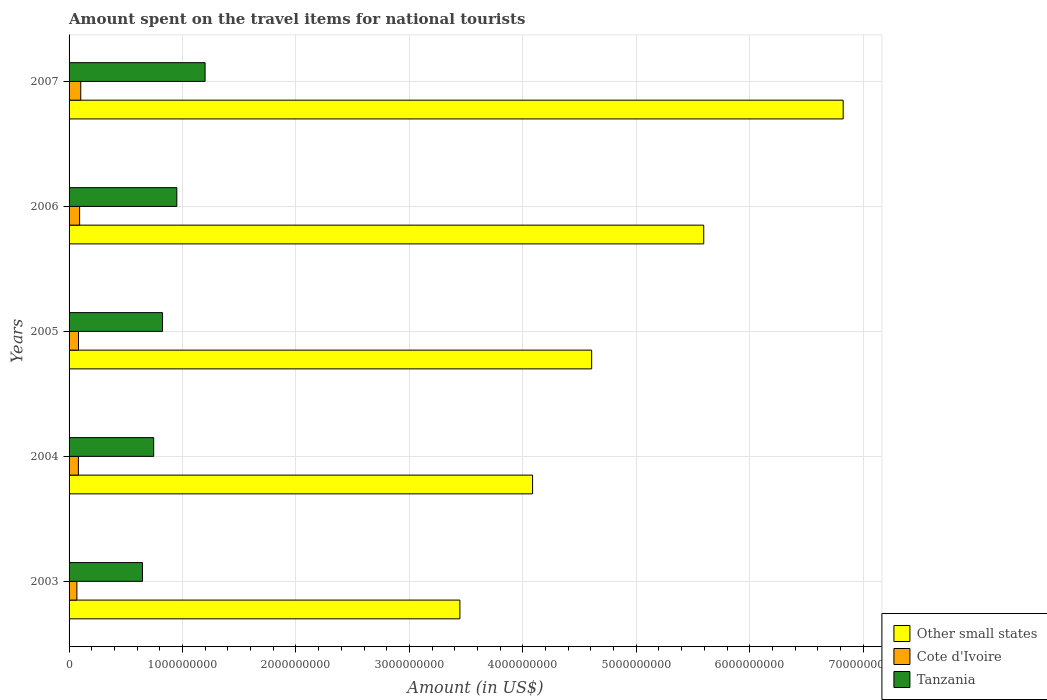How many different coloured bars are there?
Provide a short and direct response. 3. How many groups of bars are there?
Your answer should be very brief. 5. How many bars are there on the 3rd tick from the top?
Your answer should be compact. 3. How many bars are there on the 2nd tick from the bottom?
Make the answer very short. 3. What is the label of the 4th group of bars from the top?
Give a very brief answer. 2004. What is the amount spent on the travel items for national tourists in Other small states in 2005?
Provide a succinct answer. 4.61e+09. Across all years, what is the maximum amount spent on the travel items for national tourists in Other small states?
Your answer should be very brief. 6.82e+09. Across all years, what is the minimum amount spent on the travel items for national tourists in Other small states?
Ensure brevity in your answer.  3.45e+09. In which year was the amount spent on the travel items for national tourists in Tanzania maximum?
Ensure brevity in your answer.  2007. What is the total amount spent on the travel items for national tourists in Other small states in the graph?
Provide a succinct answer. 2.46e+1. What is the difference between the amount spent on the travel items for national tourists in Cote d'Ivoire in 2003 and that in 2007?
Your answer should be very brief. -3.40e+07. What is the difference between the amount spent on the travel items for national tourists in Cote d'Ivoire in 2007 and the amount spent on the travel items for national tourists in Tanzania in 2003?
Your answer should be compact. -5.44e+08. What is the average amount spent on the travel items for national tourists in Other small states per year?
Offer a very short reply. 4.91e+09. In the year 2004, what is the difference between the amount spent on the travel items for national tourists in Other small states and amount spent on the travel items for national tourists in Tanzania?
Offer a terse response. 3.34e+09. In how many years, is the amount spent on the travel items for national tourists in Cote d'Ivoire greater than 4200000000 US$?
Keep it short and to the point. 0. What is the ratio of the amount spent on the travel items for national tourists in Tanzania in 2006 to that in 2007?
Your answer should be very brief. 0.79. Is the difference between the amount spent on the travel items for national tourists in Other small states in 2003 and 2005 greater than the difference between the amount spent on the travel items for national tourists in Tanzania in 2003 and 2005?
Provide a short and direct response. No. What is the difference between the highest and the second highest amount spent on the travel items for national tourists in Other small states?
Your answer should be very brief. 1.23e+09. What is the difference between the highest and the lowest amount spent on the travel items for national tourists in Other small states?
Keep it short and to the point. 3.38e+09. In how many years, is the amount spent on the travel items for national tourists in Other small states greater than the average amount spent on the travel items for national tourists in Other small states taken over all years?
Your answer should be compact. 2. Is the sum of the amount spent on the travel items for national tourists in Tanzania in 2004 and 2006 greater than the maximum amount spent on the travel items for national tourists in Other small states across all years?
Your answer should be very brief. No. What does the 1st bar from the top in 2004 represents?
Make the answer very short. Tanzania. What does the 1st bar from the bottom in 2003 represents?
Make the answer very short. Other small states. How many bars are there?
Your answer should be very brief. 15. How many years are there in the graph?
Your answer should be compact. 5. Are the values on the major ticks of X-axis written in scientific E-notation?
Give a very brief answer. No. Does the graph contain grids?
Keep it short and to the point. Yes. Where does the legend appear in the graph?
Offer a terse response. Bottom right. How many legend labels are there?
Offer a terse response. 3. What is the title of the graph?
Provide a short and direct response. Amount spent on the travel items for national tourists. What is the label or title of the X-axis?
Offer a very short reply. Amount (in US$). What is the label or title of the Y-axis?
Give a very brief answer. Years. What is the Amount (in US$) of Other small states in 2003?
Ensure brevity in your answer.  3.45e+09. What is the Amount (in US$) of Cote d'Ivoire in 2003?
Your answer should be very brief. 6.90e+07. What is the Amount (in US$) in Tanzania in 2003?
Ensure brevity in your answer.  6.47e+08. What is the Amount (in US$) in Other small states in 2004?
Provide a short and direct response. 4.09e+09. What is the Amount (in US$) in Cote d'Ivoire in 2004?
Your response must be concise. 8.20e+07. What is the Amount (in US$) of Tanzania in 2004?
Provide a short and direct response. 7.46e+08. What is the Amount (in US$) in Other small states in 2005?
Your response must be concise. 4.61e+09. What is the Amount (in US$) of Cote d'Ivoire in 2005?
Offer a terse response. 8.30e+07. What is the Amount (in US$) in Tanzania in 2005?
Your answer should be very brief. 8.24e+08. What is the Amount (in US$) in Other small states in 2006?
Your answer should be compact. 5.59e+09. What is the Amount (in US$) of Cote d'Ivoire in 2006?
Offer a terse response. 9.30e+07. What is the Amount (in US$) in Tanzania in 2006?
Offer a terse response. 9.50e+08. What is the Amount (in US$) in Other small states in 2007?
Make the answer very short. 6.82e+09. What is the Amount (in US$) of Cote d'Ivoire in 2007?
Make the answer very short. 1.03e+08. What is the Amount (in US$) in Tanzania in 2007?
Offer a terse response. 1.20e+09. Across all years, what is the maximum Amount (in US$) of Other small states?
Your answer should be compact. 6.82e+09. Across all years, what is the maximum Amount (in US$) in Cote d'Ivoire?
Your response must be concise. 1.03e+08. Across all years, what is the maximum Amount (in US$) in Tanzania?
Ensure brevity in your answer.  1.20e+09. Across all years, what is the minimum Amount (in US$) in Other small states?
Ensure brevity in your answer.  3.45e+09. Across all years, what is the minimum Amount (in US$) of Cote d'Ivoire?
Provide a succinct answer. 6.90e+07. Across all years, what is the minimum Amount (in US$) of Tanzania?
Provide a succinct answer. 6.47e+08. What is the total Amount (in US$) of Other small states in the graph?
Offer a very short reply. 2.46e+1. What is the total Amount (in US$) of Cote d'Ivoire in the graph?
Give a very brief answer. 4.30e+08. What is the total Amount (in US$) in Tanzania in the graph?
Make the answer very short. 4.37e+09. What is the difference between the Amount (in US$) in Other small states in 2003 and that in 2004?
Your response must be concise. -6.41e+08. What is the difference between the Amount (in US$) of Cote d'Ivoire in 2003 and that in 2004?
Ensure brevity in your answer.  -1.30e+07. What is the difference between the Amount (in US$) of Tanzania in 2003 and that in 2004?
Give a very brief answer. -9.90e+07. What is the difference between the Amount (in US$) in Other small states in 2003 and that in 2005?
Give a very brief answer. -1.16e+09. What is the difference between the Amount (in US$) in Cote d'Ivoire in 2003 and that in 2005?
Offer a very short reply. -1.40e+07. What is the difference between the Amount (in US$) in Tanzania in 2003 and that in 2005?
Provide a succinct answer. -1.77e+08. What is the difference between the Amount (in US$) of Other small states in 2003 and that in 2006?
Keep it short and to the point. -2.15e+09. What is the difference between the Amount (in US$) in Cote d'Ivoire in 2003 and that in 2006?
Ensure brevity in your answer.  -2.40e+07. What is the difference between the Amount (in US$) of Tanzania in 2003 and that in 2006?
Your response must be concise. -3.03e+08. What is the difference between the Amount (in US$) in Other small states in 2003 and that in 2007?
Your response must be concise. -3.38e+09. What is the difference between the Amount (in US$) of Cote d'Ivoire in 2003 and that in 2007?
Your answer should be compact. -3.40e+07. What is the difference between the Amount (in US$) of Tanzania in 2003 and that in 2007?
Your answer should be very brief. -5.52e+08. What is the difference between the Amount (in US$) of Other small states in 2004 and that in 2005?
Provide a short and direct response. -5.21e+08. What is the difference between the Amount (in US$) in Tanzania in 2004 and that in 2005?
Give a very brief answer. -7.80e+07. What is the difference between the Amount (in US$) in Other small states in 2004 and that in 2006?
Your answer should be very brief. -1.51e+09. What is the difference between the Amount (in US$) of Cote d'Ivoire in 2004 and that in 2006?
Keep it short and to the point. -1.10e+07. What is the difference between the Amount (in US$) of Tanzania in 2004 and that in 2006?
Offer a terse response. -2.04e+08. What is the difference between the Amount (in US$) in Other small states in 2004 and that in 2007?
Make the answer very short. -2.74e+09. What is the difference between the Amount (in US$) in Cote d'Ivoire in 2004 and that in 2007?
Give a very brief answer. -2.10e+07. What is the difference between the Amount (in US$) of Tanzania in 2004 and that in 2007?
Make the answer very short. -4.53e+08. What is the difference between the Amount (in US$) of Other small states in 2005 and that in 2006?
Make the answer very short. -9.88e+08. What is the difference between the Amount (in US$) of Cote d'Ivoire in 2005 and that in 2006?
Your response must be concise. -1.00e+07. What is the difference between the Amount (in US$) in Tanzania in 2005 and that in 2006?
Make the answer very short. -1.26e+08. What is the difference between the Amount (in US$) of Other small states in 2005 and that in 2007?
Give a very brief answer. -2.22e+09. What is the difference between the Amount (in US$) in Cote d'Ivoire in 2005 and that in 2007?
Offer a very short reply. -2.00e+07. What is the difference between the Amount (in US$) in Tanzania in 2005 and that in 2007?
Offer a terse response. -3.75e+08. What is the difference between the Amount (in US$) of Other small states in 2006 and that in 2007?
Offer a very short reply. -1.23e+09. What is the difference between the Amount (in US$) of Cote d'Ivoire in 2006 and that in 2007?
Your answer should be very brief. -1.00e+07. What is the difference between the Amount (in US$) in Tanzania in 2006 and that in 2007?
Provide a short and direct response. -2.49e+08. What is the difference between the Amount (in US$) in Other small states in 2003 and the Amount (in US$) in Cote d'Ivoire in 2004?
Your answer should be compact. 3.36e+09. What is the difference between the Amount (in US$) in Other small states in 2003 and the Amount (in US$) in Tanzania in 2004?
Keep it short and to the point. 2.70e+09. What is the difference between the Amount (in US$) of Cote d'Ivoire in 2003 and the Amount (in US$) of Tanzania in 2004?
Offer a very short reply. -6.77e+08. What is the difference between the Amount (in US$) of Other small states in 2003 and the Amount (in US$) of Cote d'Ivoire in 2005?
Provide a succinct answer. 3.36e+09. What is the difference between the Amount (in US$) of Other small states in 2003 and the Amount (in US$) of Tanzania in 2005?
Your response must be concise. 2.62e+09. What is the difference between the Amount (in US$) in Cote d'Ivoire in 2003 and the Amount (in US$) in Tanzania in 2005?
Make the answer very short. -7.55e+08. What is the difference between the Amount (in US$) in Other small states in 2003 and the Amount (in US$) in Cote d'Ivoire in 2006?
Provide a short and direct response. 3.35e+09. What is the difference between the Amount (in US$) of Other small states in 2003 and the Amount (in US$) of Tanzania in 2006?
Your answer should be very brief. 2.50e+09. What is the difference between the Amount (in US$) in Cote d'Ivoire in 2003 and the Amount (in US$) in Tanzania in 2006?
Offer a terse response. -8.81e+08. What is the difference between the Amount (in US$) of Other small states in 2003 and the Amount (in US$) of Cote d'Ivoire in 2007?
Make the answer very short. 3.34e+09. What is the difference between the Amount (in US$) in Other small states in 2003 and the Amount (in US$) in Tanzania in 2007?
Give a very brief answer. 2.25e+09. What is the difference between the Amount (in US$) of Cote d'Ivoire in 2003 and the Amount (in US$) of Tanzania in 2007?
Make the answer very short. -1.13e+09. What is the difference between the Amount (in US$) in Other small states in 2004 and the Amount (in US$) in Cote d'Ivoire in 2005?
Offer a terse response. 4.00e+09. What is the difference between the Amount (in US$) in Other small states in 2004 and the Amount (in US$) in Tanzania in 2005?
Offer a terse response. 3.26e+09. What is the difference between the Amount (in US$) in Cote d'Ivoire in 2004 and the Amount (in US$) in Tanzania in 2005?
Offer a terse response. -7.42e+08. What is the difference between the Amount (in US$) of Other small states in 2004 and the Amount (in US$) of Cote d'Ivoire in 2006?
Provide a succinct answer. 3.99e+09. What is the difference between the Amount (in US$) in Other small states in 2004 and the Amount (in US$) in Tanzania in 2006?
Ensure brevity in your answer.  3.14e+09. What is the difference between the Amount (in US$) in Cote d'Ivoire in 2004 and the Amount (in US$) in Tanzania in 2006?
Keep it short and to the point. -8.68e+08. What is the difference between the Amount (in US$) of Other small states in 2004 and the Amount (in US$) of Cote d'Ivoire in 2007?
Ensure brevity in your answer.  3.98e+09. What is the difference between the Amount (in US$) of Other small states in 2004 and the Amount (in US$) of Tanzania in 2007?
Ensure brevity in your answer.  2.89e+09. What is the difference between the Amount (in US$) of Cote d'Ivoire in 2004 and the Amount (in US$) of Tanzania in 2007?
Ensure brevity in your answer.  -1.12e+09. What is the difference between the Amount (in US$) of Other small states in 2005 and the Amount (in US$) of Cote d'Ivoire in 2006?
Your answer should be very brief. 4.51e+09. What is the difference between the Amount (in US$) in Other small states in 2005 and the Amount (in US$) in Tanzania in 2006?
Your response must be concise. 3.66e+09. What is the difference between the Amount (in US$) of Cote d'Ivoire in 2005 and the Amount (in US$) of Tanzania in 2006?
Your answer should be compact. -8.67e+08. What is the difference between the Amount (in US$) in Other small states in 2005 and the Amount (in US$) in Cote d'Ivoire in 2007?
Your answer should be compact. 4.50e+09. What is the difference between the Amount (in US$) of Other small states in 2005 and the Amount (in US$) of Tanzania in 2007?
Provide a short and direct response. 3.41e+09. What is the difference between the Amount (in US$) of Cote d'Ivoire in 2005 and the Amount (in US$) of Tanzania in 2007?
Offer a very short reply. -1.12e+09. What is the difference between the Amount (in US$) of Other small states in 2006 and the Amount (in US$) of Cote d'Ivoire in 2007?
Make the answer very short. 5.49e+09. What is the difference between the Amount (in US$) of Other small states in 2006 and the Amount (in US$) of Tanzania in 2007?
Offer a very short reply. 4.40e+09. What is the difference between the Amount (in US$) in Cote d'Ivoire in 2006 and the Amount (in US$) in Tanzania in 2007?
Your response must be concise. -1.11e+09. What is the average Amount (in US$) of Other small states per year?
Offer a terse response. 4.91e+09. What is the average Amount (in US$) in Cote d'Ivoire per year?
Your answer should be compact. 8.60e+07. What is the average Amount (in US$) in Tanzania per year?
Make the answer very short. 8.73e+08. In the year 2003, what is the difference between the Amount (in US$) of Other small states and Amount (in US$) of Cote d'Ivoire?
Ensure brevity in your answer.  3.38e+09. In the year 2003, what is the difference between the Amount (in US$) of Other small states and Amount (in US$) of Tanzania?
Make the answer very short. 2.80e+09. In the year 2003, what is the difference between the Amount (in US$) in Cote d'Ivoire and Amount (in US$) in Tanzania?
Ensure brevity in your answer.  -5.78e+08. In the year 2004, what is the difference between the Amount (in US$) of Other small states and Amount (in US$) of Cote d'Ivoire?
Your response must be concise. 4.00e+09. In the year 2004, what is the difference between the Amount (in US$) of Other small states and Amount (in US$) of Tanzania?
Offer a terse response. 3.34e+09. In the year 2004, what is the difference between the Amount (in US$) in Cote d'Ivoire and Amount (in US$) in Tanzania?
Ensure brevity in your answer.  -6.64e+08. In the year 2005, what is the difference between the Amount (in US$) of Other small states and Amount (in US$) of Cote d'Ivoire?
Your answer should be compact. 4.52e+09. In the year 2005, what is the difference between the Amount (in US$) in Other small states and Amount (in US$) in Tanzania?
Give a very brief answer. 3.78e+09. In the year 2005, what is the difference between the Amount (in US$) in Cote d'Ivoire and Amount (in US$) in Tanzania?
Provide a short and direct response. -7.41e+08. In the year 2006, what is the difference between the Amount (in US$) in Other small states and Amount (in US$) in Cote d'Ivoire?
Offer a terse response. 5.50e+09. In the year 2006, what is the difference between the Amount (in US$) of Other small states and Amount (in US$) of Tanzania?
Keep it short and to the point. 4.64e+09. In the year 2006, what is the difference between the Amount (in US$) in Cote d'Ivoire and Amount (in US$) in Tanzania?
Your answer should be compact. -8.57e+08. In the year 2007, what is the difference between the Amount (in US$) of Other small states and Amount (in US$) of Cote d'Ivoire?
Give a very brief answer. 6.72e+09. In the year 2007, what is the difference between the Amount (in US$) in Other small states and Amount (in US$) in Tanzania?
Ensure brevity in your answer.  5.63e+09. In the year 2007, what is the difference between the Amount (in US$) of Cote d'Ivoire and Amount (in US$) of Tanzania?
Provide a short and direct response. -1.10e+09. What is the ratio of the Amount (in US$) of Other small states in 2003 to that in 2004?
Provide a succinct answer. 0.84. What is the ratio of the Amount (in US$) of Cote d'Ivoire in 2003 to that in 2004?
Your response must be concise. 0.84. What is the ratio of the Amount (in US$) in Tanzania in 2003 to that in 2004?
Provide a succinct answer. 0.87. What is the ratio of the Amount (in US$) of Other small states in 2003 to that in 2005?
Your answer should be very brief. 0.75. What is the ratio of the Amount (in US$) of Cote d'Ivoire in 2003 to that in 2005?
Give a very brief answer. 0.83. What is the ratio of the Amount (in US$) in Tanzania in 2003 to that in 2005?
Give a very brief answer. 0.79. What is the ratio of the Amount (in US$) in Other small states in 2003 to that in 2006?
Offer a very short reply. 0.62. What is the ratio of the Amount (in US$) of Cote d'Ivoire in 2003 to that in 2006?
Provide a short and direct response. 0.74. What is the ratio of the Amount (in US$) in Tanzania in 2003 to that in 2006?
Offer a very short reply. 0.68. What is the ratio of the Amount (in US$) of Other small states in 2003 to that in 2007?
Ensure brevity in your answer.  0.5. What is the ratio of the Amount (in US$) of Cote d'Ivoire in 2003 to that in 2007?
Offer a very short reply. 0.67. What is the ratio of the Amount (in US$) of Tanzania in 2003 to that in 2007?
Ensure brevity in your answer.  0.54. What is the ratio of the Amount (in US$) of Other small states in 2004 to that in 2005?
Your response must be concise. 0.89. What is the ratio of the Amount (in US$) of Tanzania in 2004 to that in 2005?
Ensure brevity in your answer.  0.91. What is the ratio of the Amount (in US$) in Other small states in 2004 to that in 2006?
Your answer should be very brief. 0.73. What is the ratio of the Amount (in US$) of Cote d'Ivoire in 2004 to that in 2006?
Ensure brevity in your answer.  0.88. What is the ratio of the Amount (in US$) in Tanzania in 2004 to that in 2006?
Provide a succinct answer. 0.79. What is the ratio of the Amount (in US$) of Other small states in 2004 to that in 2007?
Keep it short and to the point. 0.6. What is the ratio of the Amount (in US$) of Cote d'Ivoire in 2004 to that in 2007?
Provide a short and direct response. 0.8. What is the ratio of the Amount (in US$) in Tanzania in 2004 to that in 2007?
Your answer should be very brief. 0.62. What is the ratio of the Amount (in US$) of Other small states in 2005 to that in 2006?
Make the answer very short. 0.82. What is the ratio of the Amount (in US$) in Cote d'Ivoire in 2005 to that in 2006?
Your response must be concise. 0.89. What is the ratio of the Amount (in US$) of Tanzania in 2005 to that in 2006?
Offer a very short reply. 0.87. What is the ratio of the Amount (in US$) of Other small states in 2005 to that in 2007?
Give a very brief answer. 0.68. What is the ratio of the Amount (in US$) of Cote d'Ivoire in 2005 to that in 2007?
Make the answer very short. 0.81. What is the ratio of the Amount (in US$) in Tanzania in 2005 to that in 2007?
Provide a short and direct response. 0.69. What is the ratio of the Amount (in US$) in Other small states in 2006 to that in 2007?
Keep it short and to the point. 0.82. What is the ratio of the Amount (in US$) in Cote d'Ivoire in 2006 to that in 2007?
Ensure brevity in your answer.  0.9. What is the ratio of the Amount (in US$) in Tanzania in 2006 to that in 2007?
Give a very brief answer. 0.79. What is the difference between the highest and the second highest Amount (in US$) of Other small states?
Keep it short and to the point. 1.23e+09. What is the difference between the highest and the second highest Amount (in US$) of Cote d'Ivoire?
Ensure brevity in your answer.  1.00e+07. What is the difference between the highest and the second highest Amount (in US$) in Tanzania?
Make the answer very short. 2.49e+08. What is the difference between the highest and the lowest Amount (in US$) of Other small states?
Give a very brief answer. 3.38e+09. What is the difference between the highest and the lowest Amount (in US$) of Cote d'Ivoire?
Offer a very short reply. 3.40e+07. What is the difference between the highest and the lowest Amount (in US$) of Tanzania?
Provide a short and direct response. 5.52e+08. 